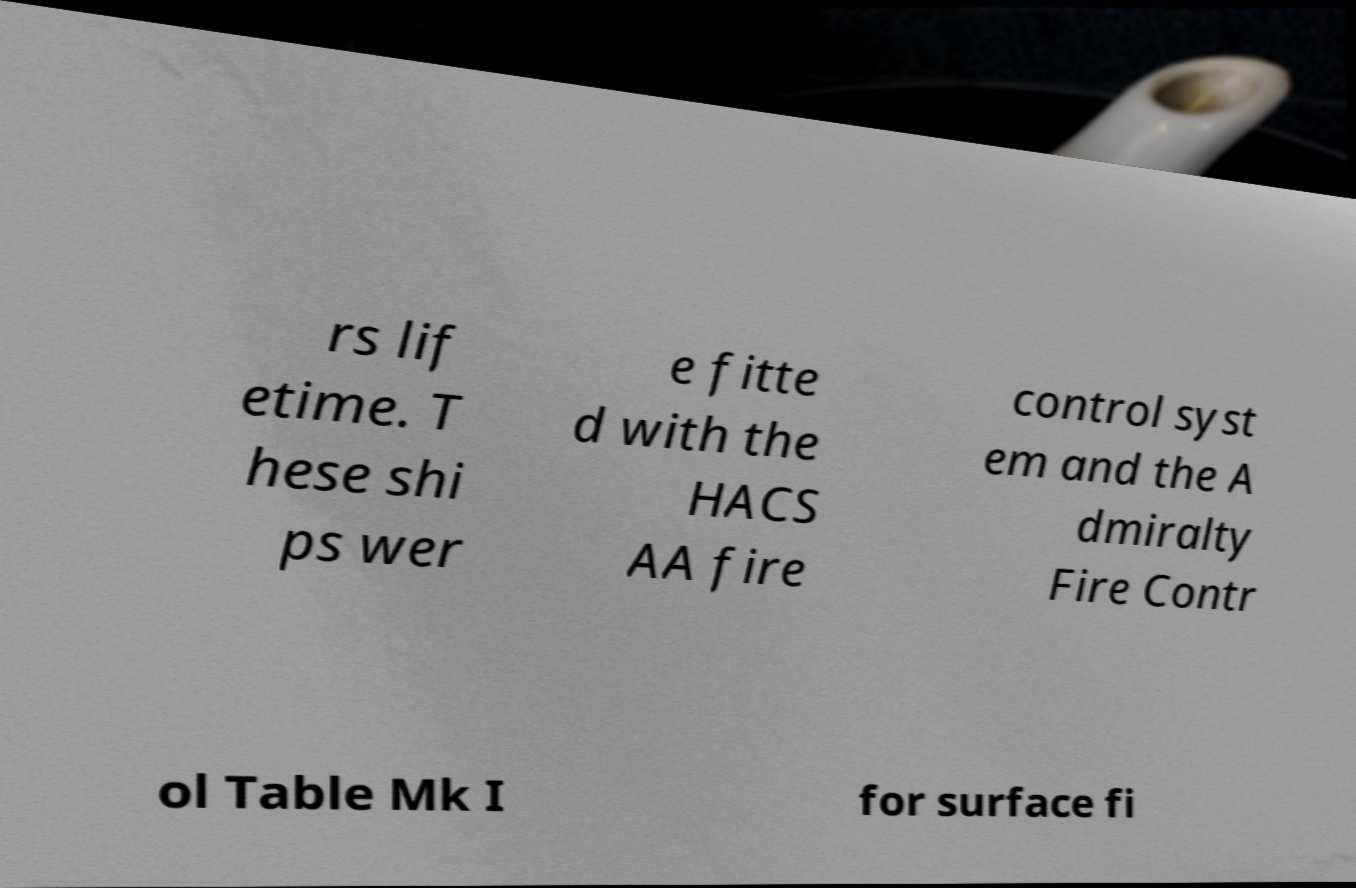What messages or text are displayed in this image? I need them in a readable, typed format. rs lif etime. T hese shi ps wer e fitte d with the HACS AA fire control syst em and the A dmiralty Fire Contr ol Table Mk I for surface fi 